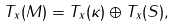<formula> <loc_0><loc_0><loc_500><loc_500>T _ { x } ( M ) = T _ { x } ( \kappa ) \oplus T _ { x } ( S ) ,</formula> 